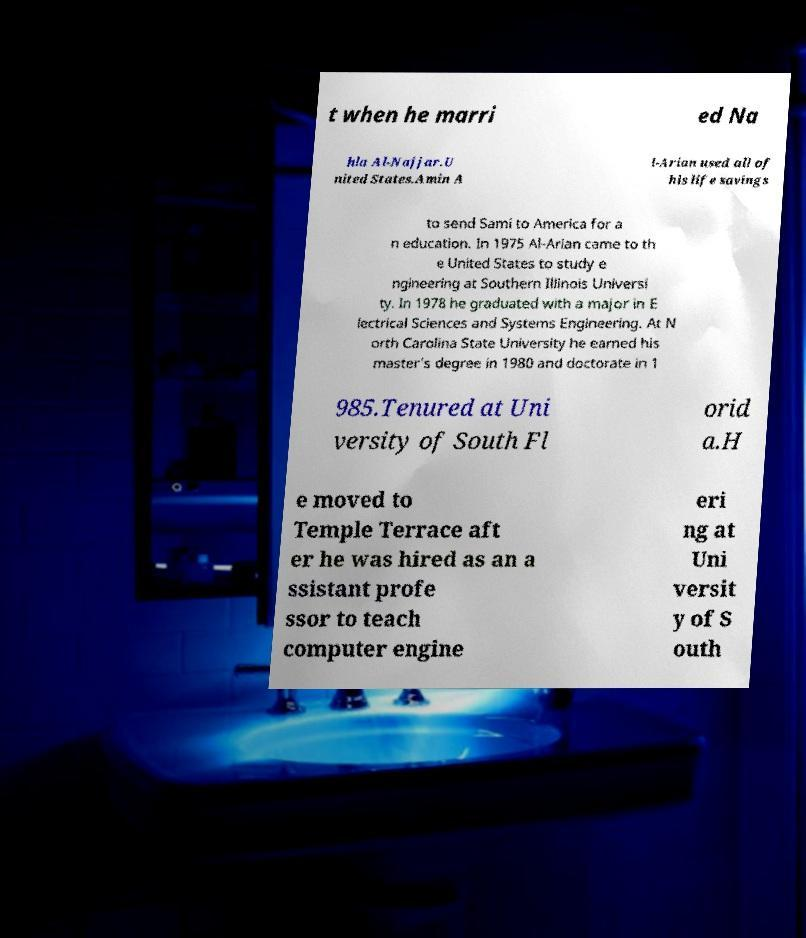Can you accurately transcribe the text from the provided image for me? t when he marri ed Na hla Al-Najjar.U nited States.Amin A l-Arian used all of his life savings to send Sami to America for a n education. In 1975 Al-Arian came to th e United States to study e ngineering at Southern Illinois Universi ty. In 1978 he graduated with a major in E lectrical Sciences and Systems Engineering. At N orth Carolina State University he earned his master's degree in 1980 and doctorate in 1 985.Tenured at Uni versity of South Fl orid a.H e moved to Temple Terrace aft er he was hired as an a ssistant profe ssor to teach computer engine eri ng at Uni versit y of S outh 